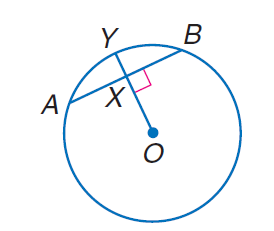Question: Circle O has a radius of 10, A B = 10 and m \overrightarrow A B = 60. Find m \widehat A X.
Choices:
A. 5
B. 10
C. 20
D. 30
Answer with the letter. Answer: A Question: Circle O has a radius of 10, A B = 10 and m \overrightarrow A B = 60. Find m \widehat A Y.
Choices:
A. 10
B. 30
C. 60
D. 90
Answer with the letter. Answer: B Question: Circle O has a radius of 10, A B = 10 and m \overrightarrow A B = 60. Find m \widehat O X.
Choices:
A. 5
B. 5 \sqrt { 3 }
C. 10
D. 15
Answer with the letter. Answer: B 